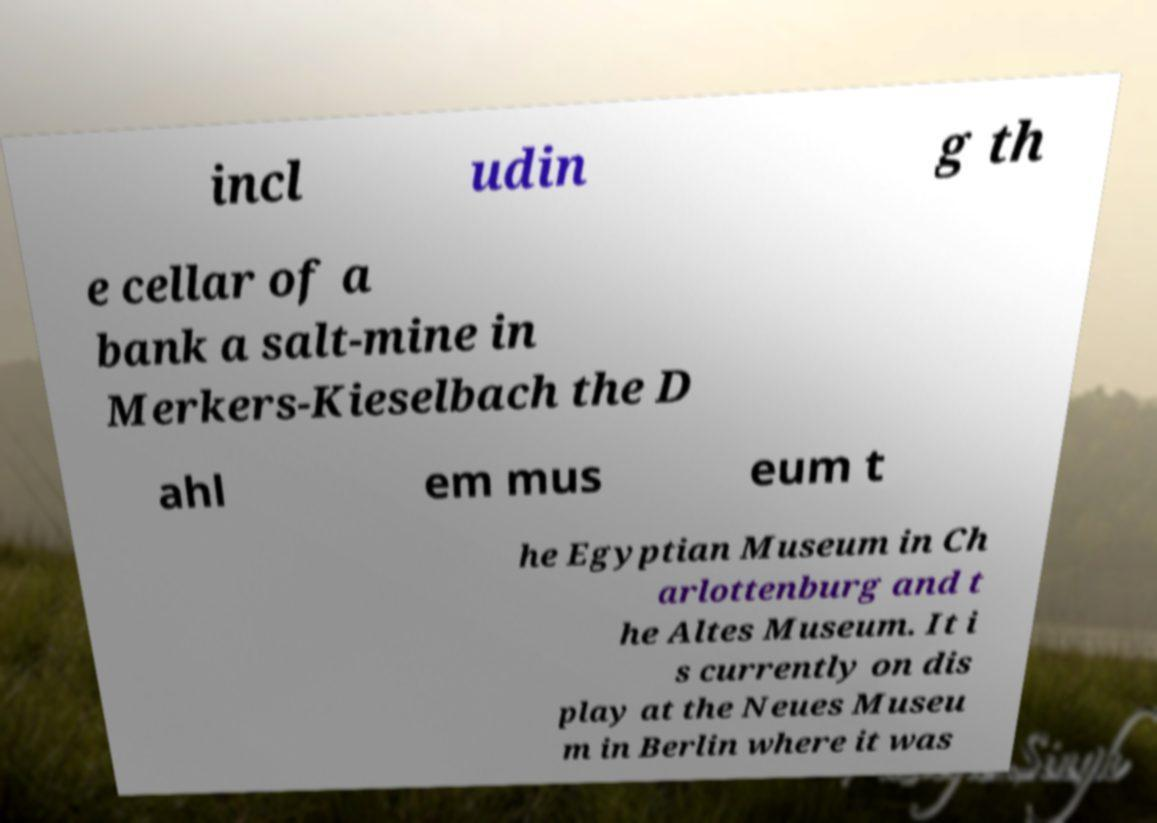Can you accurately transcribe the text from the provided image for me? incl udin g th e cellar of a bank a salt-mine in Merkers-Kieselbach the D ahl em mus eum t he Egyptian Museum in Ch arlottenburg and t he Altes Museum. It i s currently on dis play at the Neues Museu m in Berlin where it was 